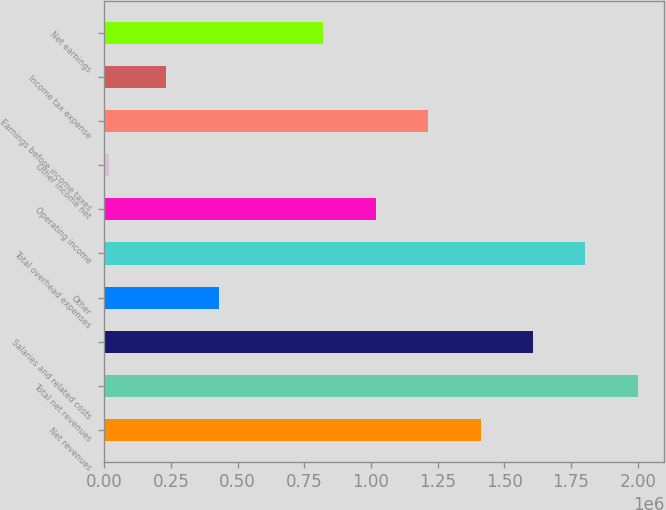<chart> <loc_0><loc_0><loc_500><loc_500><bar_chart><fcel>Net revenues<fcel>Total net revenues<fcel>Salaries and related costs<fcel>Other<fcel>Total overhead expenses<fcel>Operating income<fcel>Other income net<fcel>Earnings before income taxes<fcel>Income tax expense<fcel>Net earnings<nl><fcel>1.41054e+06<fcel>2.0001e+06<fcel>1.60706e+06<fcel>427948<fcel>1.80358e+06<fcel>1.0175e+06<fcel>16241<fcel>1.21402e+06<fcel>231429<fcel>820985<nl></chart> 